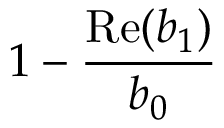Convert formula to latex. <formula><loc_0><loc_0><loc_500><loc_500>1 - \frac { R e ( b _ { 1 } ) } { b _ { 0 } }</formula> 